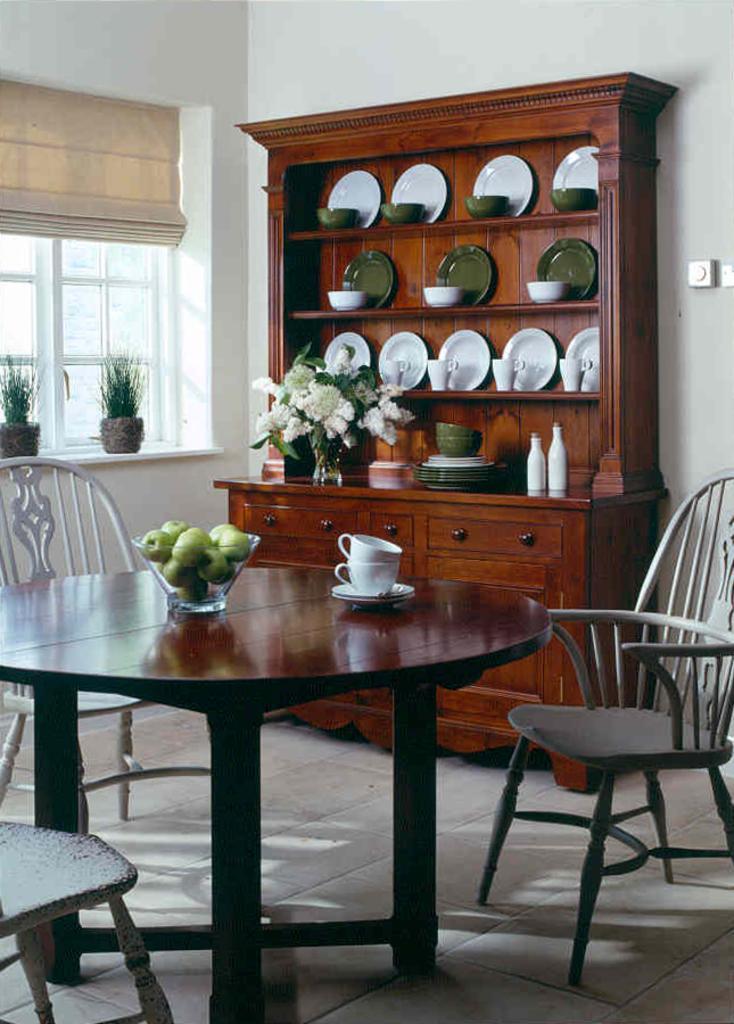In one or two sentences, can you explain what this image depicts? This picture is clicked inside. In the center we can see the cups, saucers and a bowl containing some fruits seems to be the green apples, are placed on the top of the wooden table and we can see the chairs, house plants, window, window blind and a wooden cabinet containing platters, bowls, cups, bottles, flower vase and some other items. In the background there is a wall. 